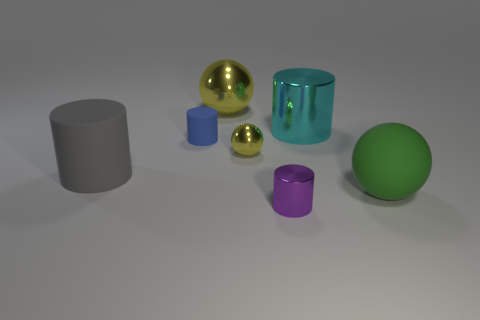Subtract all metal spheres. How many spheres are left? 1 Add 3 tiny yellow cylinders. How many objects exist? 10 Subtract all green spheres. How many spheres are left? 2 Subtract 3 cylinders. How many cylinders are left? 1 Add 3 large spheres. How many large spheres exist? 5 Subtract 1 yellow spheres. How many objects are left? 6 Subtract all spheres. How many objects are left? 4 Subtract all purple balls. Subtract all green cylinders. How many balls are left? 3 Subtract all blue spheres. How many green cylinders are left? 0 Subtract all large cyan objects. Subtract all green things. How many objects are left? 5 